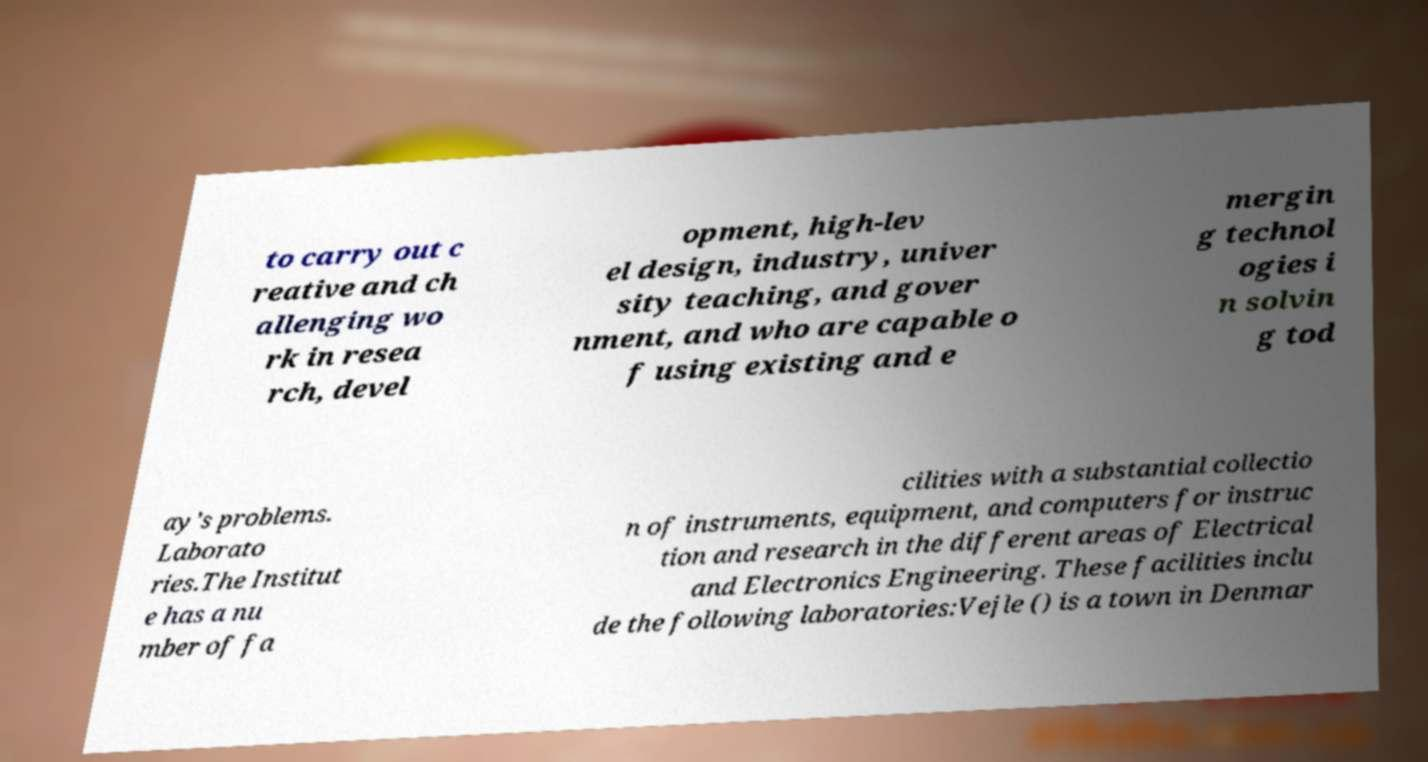What messages or text are displayed in this image? I need them in a readable, typed format. to carry out c reative and ch allenging wo rk in resea rch, devel opment, high-lev el design, industry, univer sity teaching, and gover nment, and who are capable o f using existing and e mergin g technol ogies i n solvin g tod ay’s problems. Laborato ries.The Institut e has a nu mber of fa cilities with a substantial collectio n of instruments, equipment, and computers for instruc tion and research in the different areas of Electrical and Electronics Engineering. These facilities inclu de the following laboratories:Vejle () is a town in Denmar 